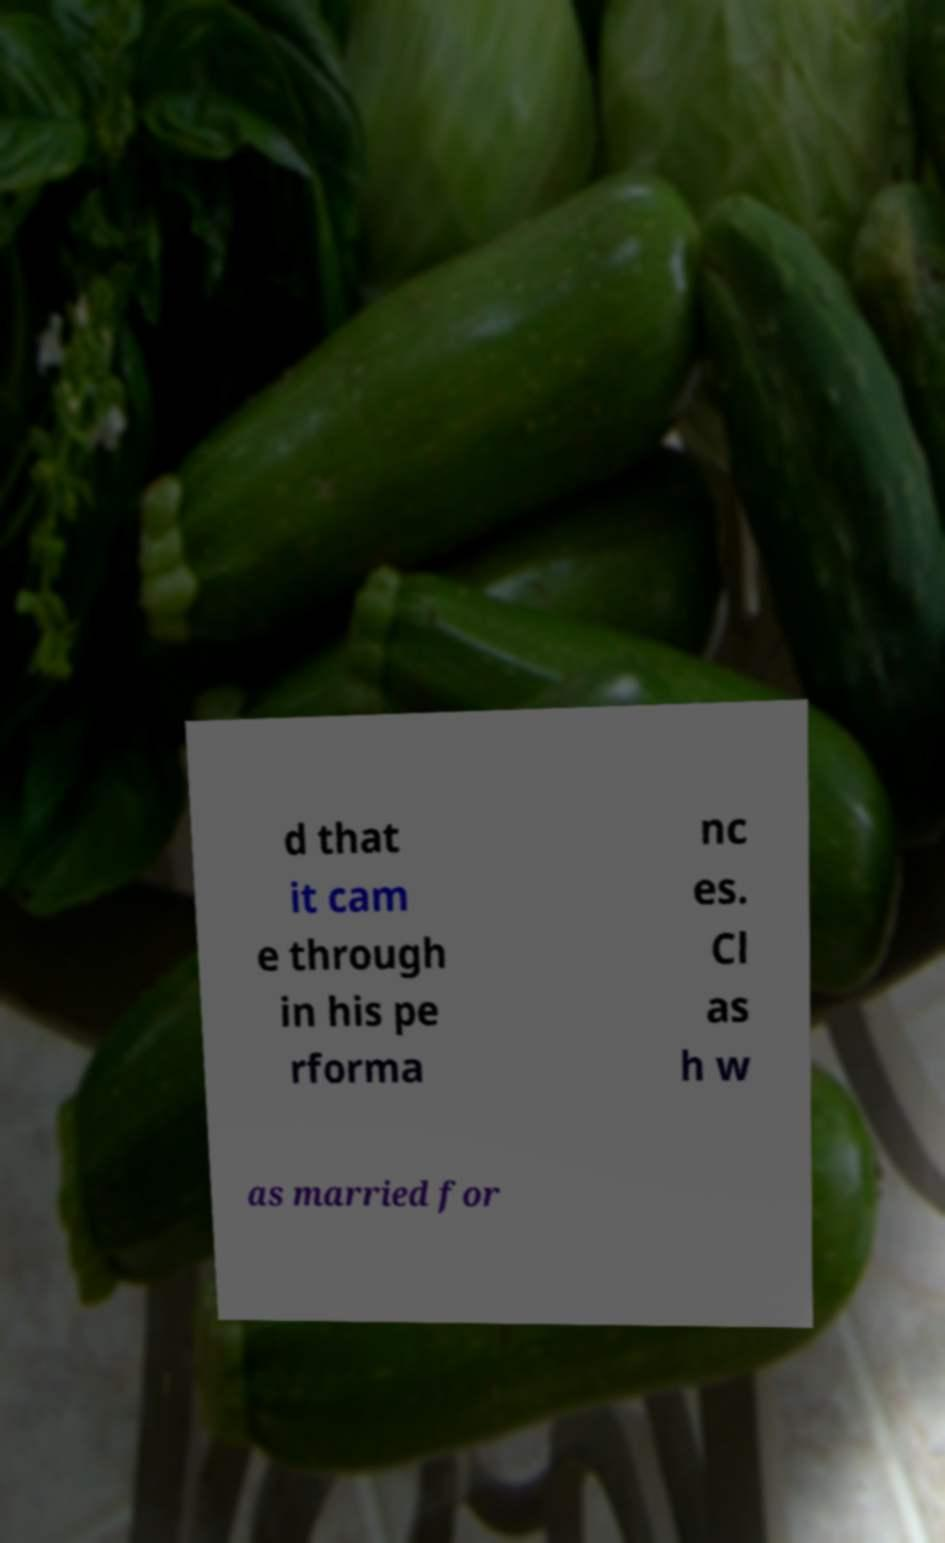Could you assist in decoding the text presented in this image and type it out clearly? d that it cam e through in his pe rforma nc es. Cl as h w as married for 